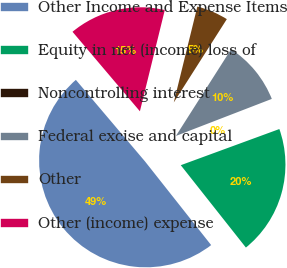<chart> <loc_0><loc_0><loc_500><loc_500><pie_chart><fcel>Other Income and Expense Items<fcel>Equity in net (income) loss of<fcel>Noncontrolling interest<fcel>Federal excise and capital<fcel>Other<fcel>Other (income) expense<nl><fcel>49.46%<fcel>19.95%<fcel>0.27%<fcel>10.11%<fcel>5.19%<fcel>15.03%<nl></chart> 